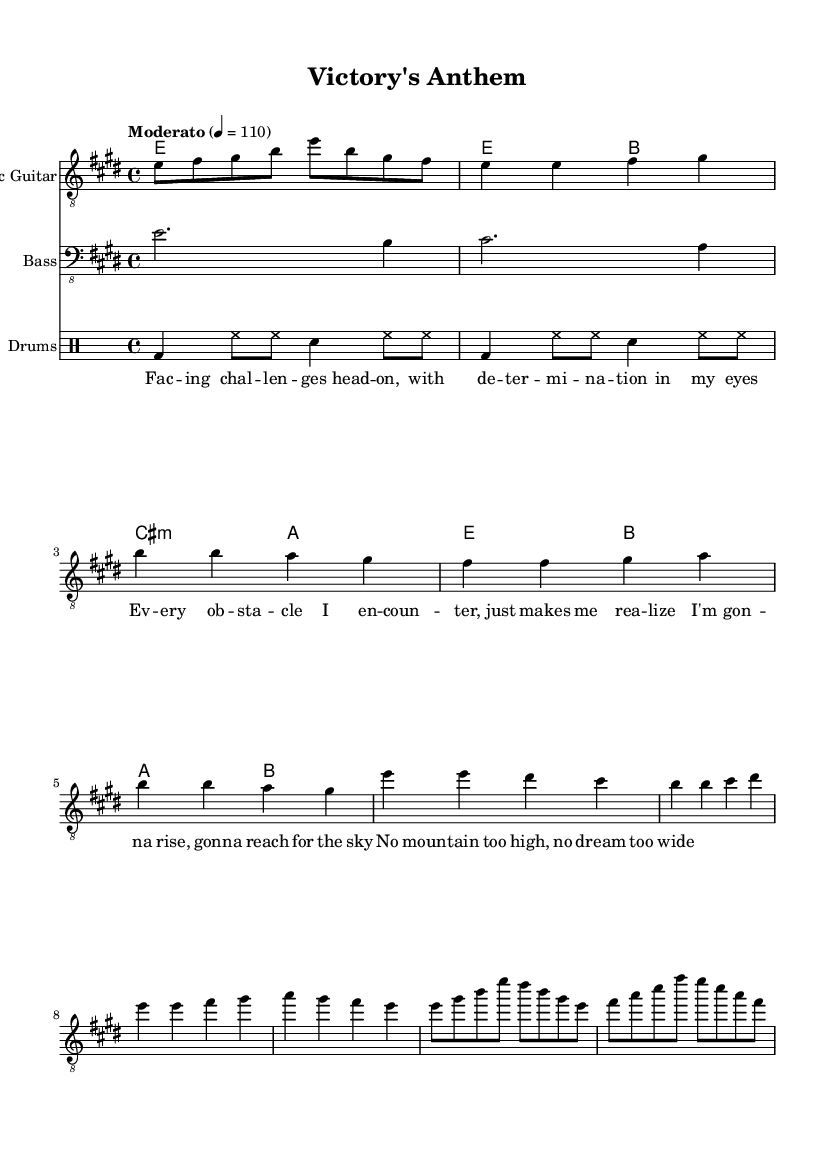What is the key signature of this music? The key signature is E major, which has four sharps: F sharp, C sharp, G sharp, and D sharp.
Answer: E major What is the time signature of this music? The time signature is 4/4, indicating that there are four beats in each measure and the quarter note gets one beat.
Answer: 4/4 What is the tempo marking of the music? The tempo marking indicates "Moderato," which suggests a moderate speed; the metronome marking of 110 beats per minute is also specified.
Answer: Moderato How many measures are in the chorus section? The chorus consists of four measures, as indicated by the music notes in that section on the score.
Answer: Four Which instrument plays the melody prominently? The electric guitar plays the melody prominently throughout the piece, as indicated by its relative clef and staff placement.
Answer: Electric guitar What is the primary theme expressed in the lyrics? The primary theme expressed in the lyrics is overcoming challenges and striving for success, highlighted by phrases about determination and reaching for the sky.
Answer: Overcoming challenges What type of chord is used in the second measure? The second measure uses a B major chord, which is identified by the notes played in the chord structure.
Answer: B major 